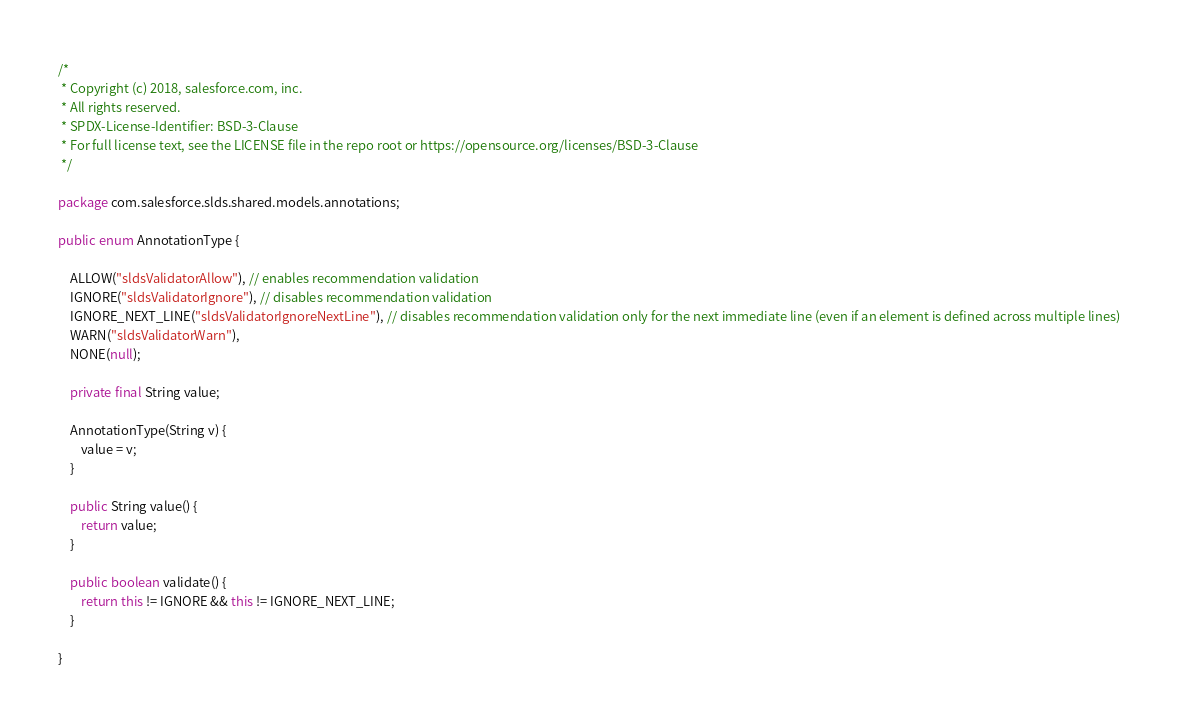<code> <loc_0><loc_0><loc_500><loc_500><_Java_>/*
 * Copyright (c) 2018, salesforce.com, inc.
 * All rights reserved.
 * SPDX-License-Identifier: BSD-3-Clause
 * For full license text, see the LICENSE file in the repo root or https://opensource.org/licenses/BSD-3-Clause
 */

package com.salesforce.slds.shared.models.annotations;

public enum AnnotationType {

    ALLOW("sldsValidatorAllow"), // enables recommendation validation
    IGNORE("sldsValidatorIgnore"), // disables recommendation validation
    IGNORE_NEXT_LINE("sldsValidatorIgnoreNextLine"), // disables recommendation validation only for the next immediate line (even if an element is defined across multiple lines)
    WARN("sldsValidatorWarn"),
    NONE(null);

    private final String value;

    AnnotationType(String v) {
        value = v;
    }

    public String value() {
        return value;
    }

    public boolean validate() {
        return this != IGNORE && this != IGNORE_NEXT_LINE;
    }

}</code> 